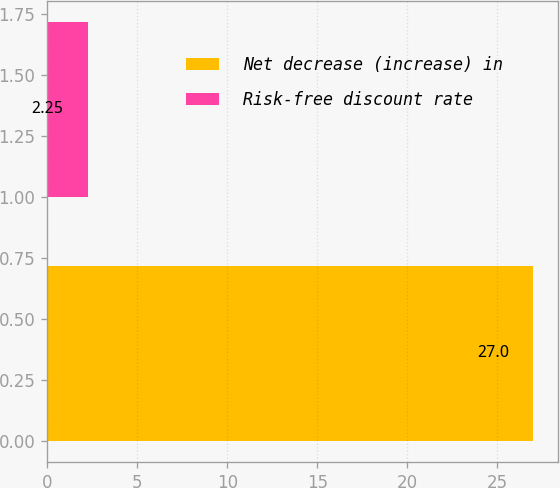<chart> <loc_0><loc_0><loc_500><loc_500><bar_chart><fcel>Net decrease (increase) in<fcel>Risk-free discount rate<nl><fcel>27<fcel>2.25<nl></chart> 